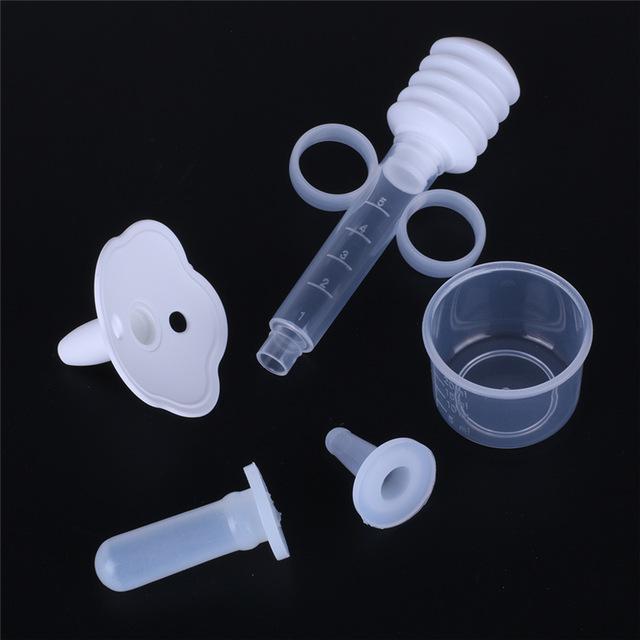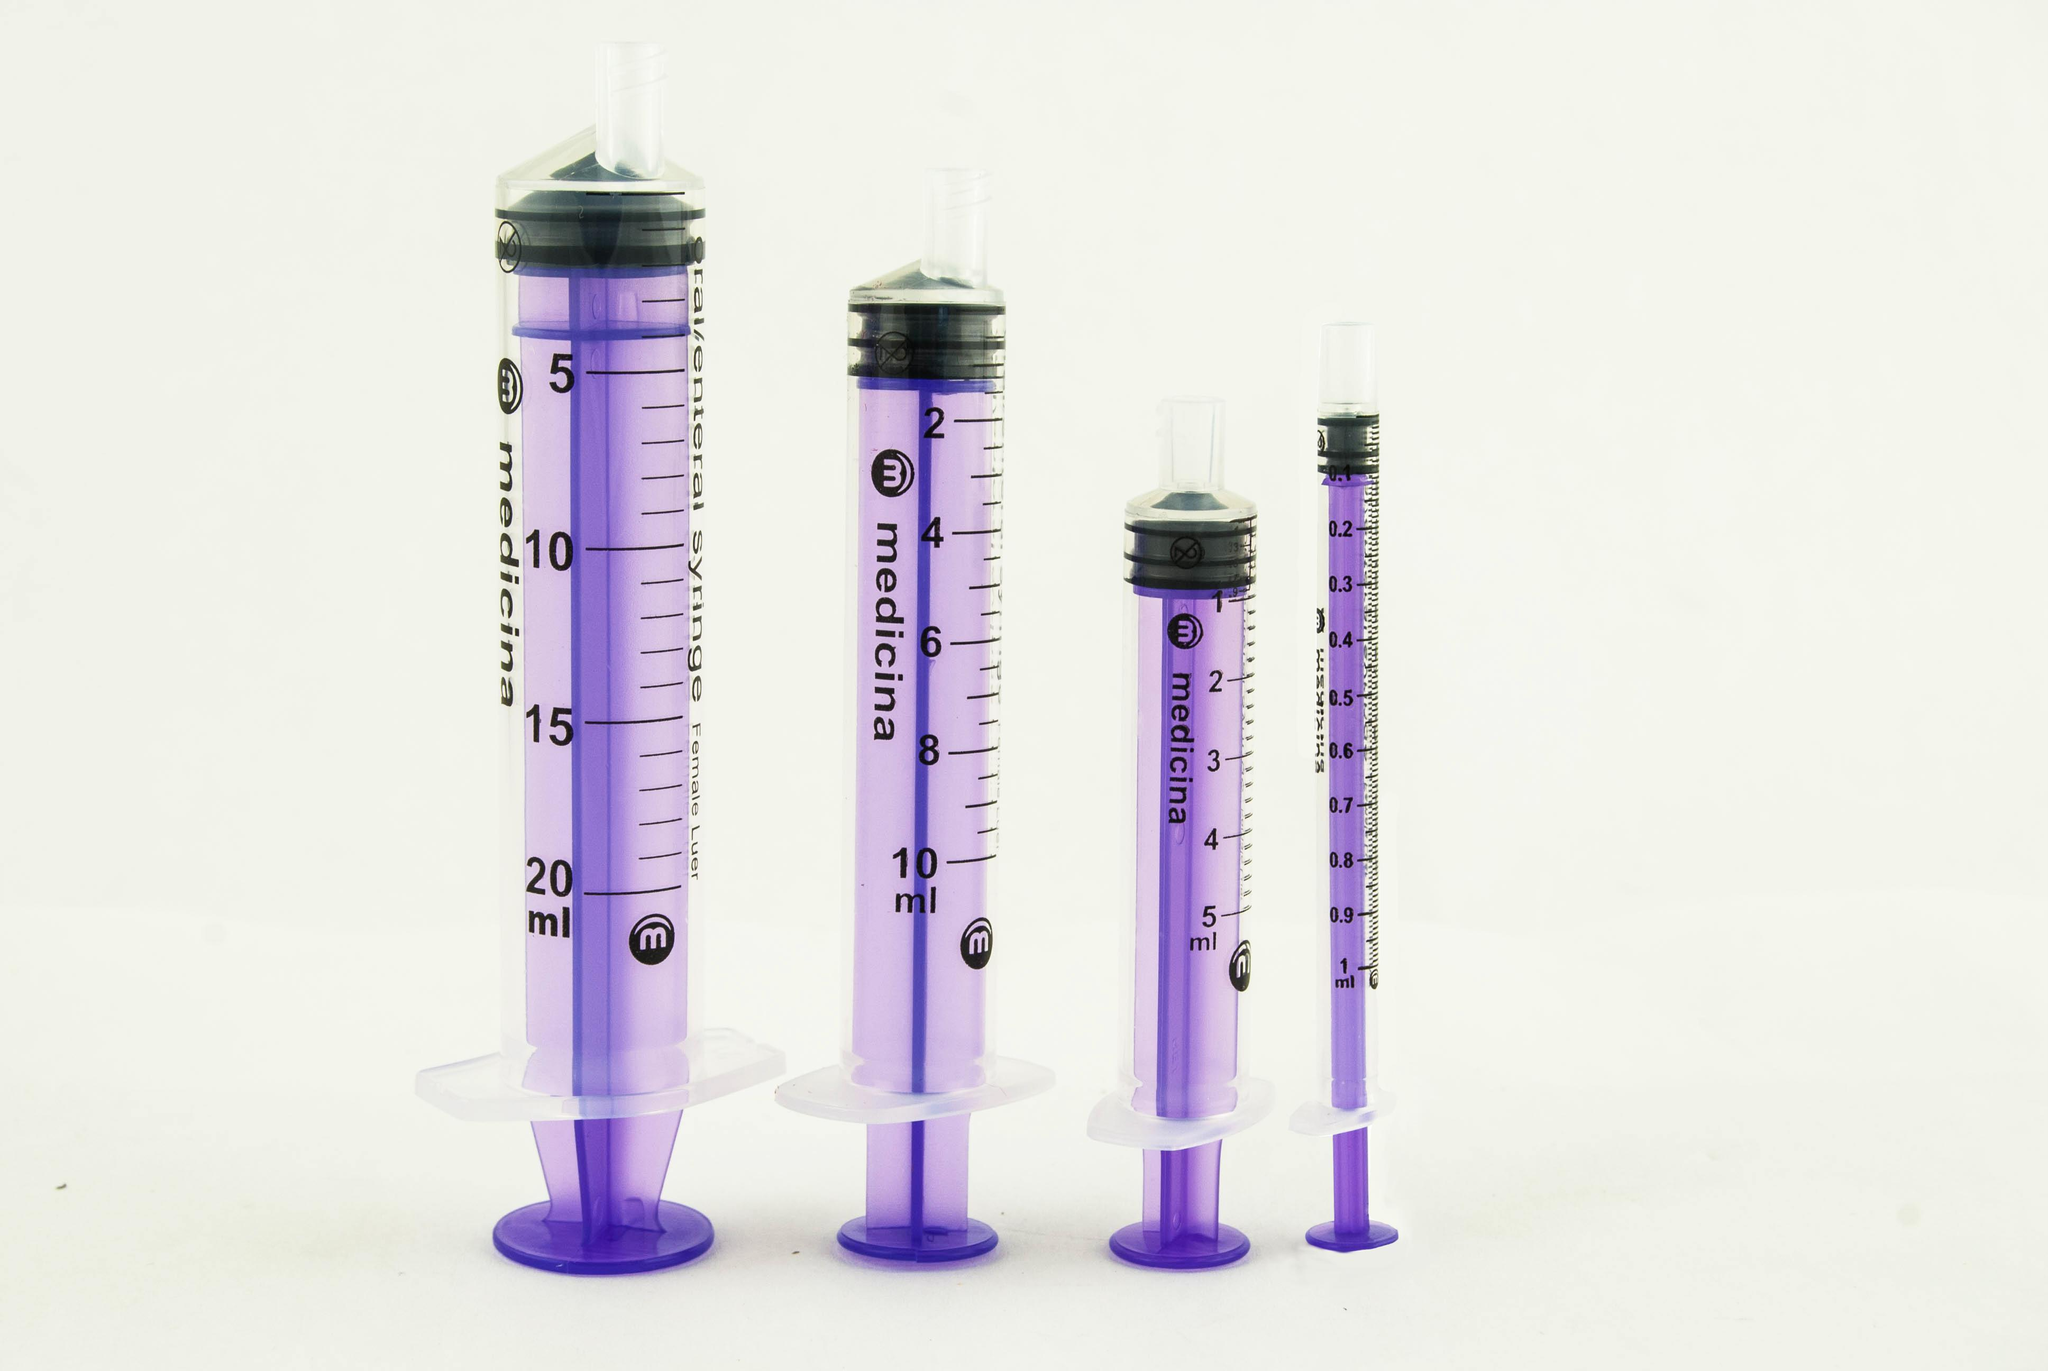The first image is the image on the left, the second image is the image on the right. Given the left and right images, does the statement "There are exactly four syringes in one of the images." hold true? Answer yes or no. Yes. 